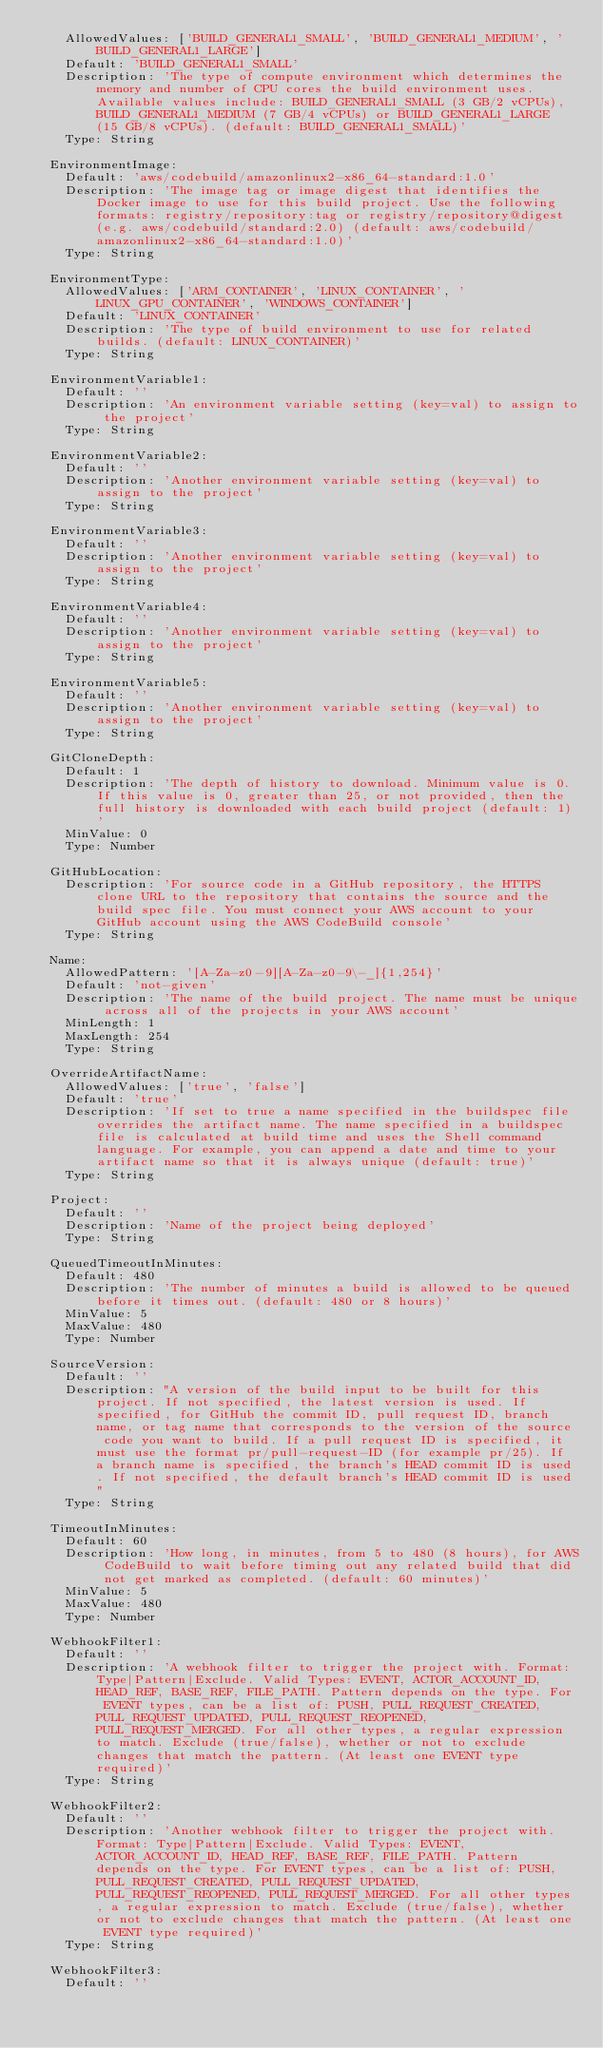<code> <loc_0><loc_0><loc_500><loc_500><_YAML_>    AllowedValues: ['BUILD_GENERAL1_SMALL', 'BUILD_GENERAL1_MEDIUM', 'BUILD_GENERAL1_LARGE']
    Default: 'BUILD_GENERAL1_SMALL'
    Description: 'The type of compute environment which determines the memory and number of CPU cores the build environment uses. Available values include: BUILD_GENERAL1_SMALL (3 GB/2 vCPUs), BUILD_GENERAL1_MEDIUM (7 GB/4 vCPUs) or BUILD_GENERAL1_LARGE (15 GB/8 vCPUs). (default: BUILD_GENERAL1_SMALL)'
    Type: String

  EnvironmentImage:
    Default: 'aws/codebuild/amazonlinux2-x86_64-standard:1.0'
    Description: 'The image tag or image digest that identifies the Docker image to use for this build project. Use the following formats: registry/repository:tag or registry/repository@digest (e.g. aws/codebuild/standard:2.0) (default: aws/codebuild/amazonlinux2-x86_64-standard:1.0)'
    Type: String

  EnvironmentType:
    AllowedValues: ['ARM_CONTAINER', 'LINUX_CONTAINER', 'LINUX_GPU_CONTAINER', 'WINDOWS_CONTAINER']
    Default: 'LINUX_CONTAINER'
    Description: 'The type of build environment to use for related builds. (default: LINUX_CONTAINER)'
    Type: String

  EnvironmentVariable1:
    Default: ''
    Description: 'An environment variable setting (key=val) to assign to the project'
    Type: String

  EnvironmentVariable2:
    Default: ''
    Description: 'Another environment variable setting (key=val) to assign to the project'
    Type: String

  EnvironmentVariable3:
    Default: ''
    Description: 'Another environment variable setting (key=val) to assign to the project'
    Type: String

  EnvironmentVariable4:
    Default: ''
    Description: 'Another environment variable setting (key=val) to assign to the project'
    Type: String

  EnvironmentVariable5:
    Default: ''
    Description: 'Another environment variable setting (key=val) to assign to the project'
    Type: String

  GitCloneDepth:
    Default: 1
    Description: 'The depth of history to download. Minimum value is 0. If this value is 0, greater than 25, or not provided, then the full history is downloaded with each build project (default: 1)'
    MinValue: 0
    Type: Number

  GitHubLocation:
    Description: 'For source code in a GitHub repository, the HTTPS clone URL to the repository that contains the source and the build spec file. You must connect your AWS account to your GitHub account using the AWS CodeBuild console'
    Type: String

  Name:
    AllowedPattern: '[A-Za-z0-9][A-Za-z0-9\-_]{1,254}'
    Default: 'not-given'
    Description: 'The name of the build project. The name must be unique across all of the projects in your AWS account'
    MinLength: 1
    MaxLength: 254
    Type: String

  OverrideArtifactName:
    AllowedValues: ['true', 'false']
    Default: 'true'
    Description: 'If set to true a name specified in the buildspec file overrides the artifact name. The name specified in a buildspec file is calculated at build time and uses the Shell command language. For example, you can append a date and time to your artifact name so that it is always unique (default: true)'
    Type: String

  Project:
    Default: ''
    Description: 'Name of the project being deployed'
    Type: String

  QueuedTimeoutInMinutes:
    Default: 480
    Description: 'The number of minutes a build is allowed to be queued before it times out. (default: 480 or 8 hours)'
    MinValue: 5
    MaxValue: 480
    Type: Number

  SourceVersion:
    Default: ''
    Description: "A version of the build input to be built for this project. If not specified, the latest version is used. If specified, for GitHub the commit ID, pull request ID, branch name, or tag name that corresponds to the version of the source code you want to build. If a pull request ID is specified, it must use the format pr/pull-request-ID (for example pr/25). If a branch name is specified, the branch's HEAD commit ID is used. If not specified, the default branch's HEAD commit ID is used"
    Type: String

  TimeoutInMinutes:
    Default: 60
    Description: 'How long, in minutes, from 5 to 480 (8 hours), for AWS CodeBuild to wait before timing out any related build that did not get marked as completed. (default: 60 minutes)'
    MinValue: 5
    MaxValue: 480
    Type: Number

  WebhookFilter1:
    Default: ''
    Description: 'A webhook filter to trigger the project with. Format: Type|Pattern|Exclude. Valid Types: EVENT, ACTOR_ACCOUNT_ID, HEAD_REF, BASE_REF, FILE_PATH. Pattern depends on the type. For EVENT types, can be a list of: PUSH, PULL_REQUEST_CREATED, PULL_REQUEST_UPDATED, PULL_REQUEST_REOPENED, PULL_REQUEST_MERGED. For all other types, a regular expression to match. Exclude (true/false), whether or not to exclude changes that match the pattern. (At least one EVENT type required)'
    Type: String

  WebhookFilter2:
    Default: ''
    Description: 'Another webhook filter to trigger the project with. Format: Type|Pattern|Exclude. Valid Types: EVENT, ACTOR_ACCOUNT_ID, HEAD_REF, BASE_REF, FILE_PATH. Pattern depends on the type. For EVENT types, can be a list of: PUSH, PULL_REQUEST_CREATED, PULL_REQUEST_UPDATED, PULL_REQUEST_REOPENED, PULL_REQUEST_MERGED. For all other types, a regular expression to match. Exclude (true/false), whether or not to exclude changes that match the pattern. (At least one EVENT type required)'
    Type: String

  WebhookFilter3:
    Default: ''</code> 